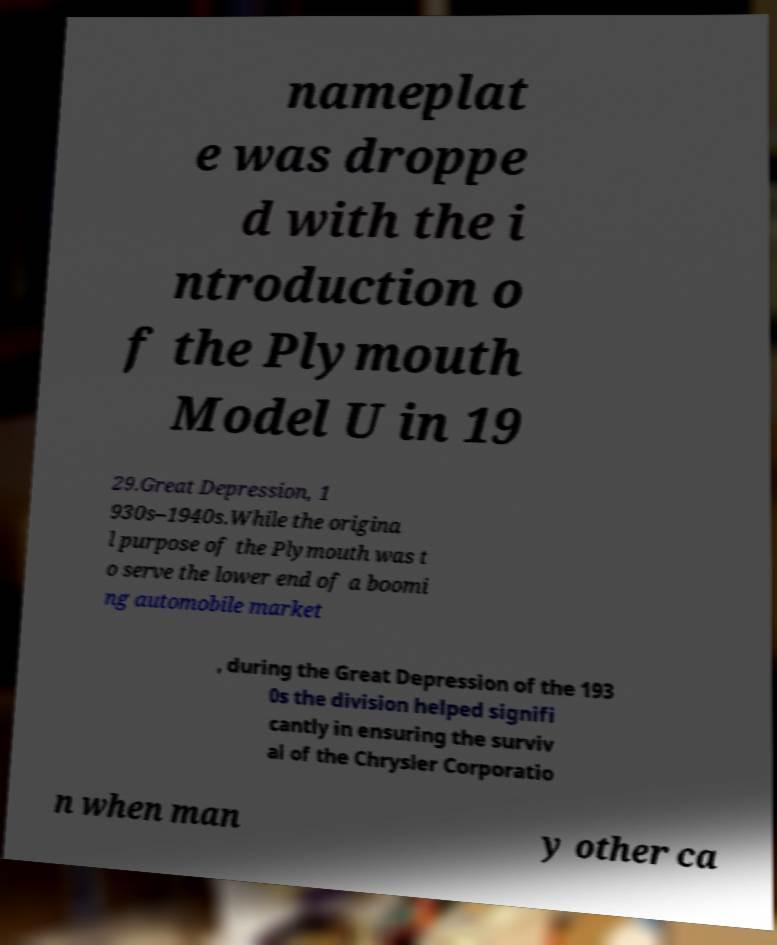Please read and relay the text visible in this image. What does it say? nameplat e was droppe d with the i ntroduction o f the Plymouth Model U in 19 29.Great Depression, 1 930s–1940s.While the origina l purpose of the Plymouth was t o serve the lower end of a boomi ng automobile market , during the Great Depression of the 193 0s the division helped signifi cantly in ensuring the surviv al of the Chrysler Corporatio n when man y other ca 